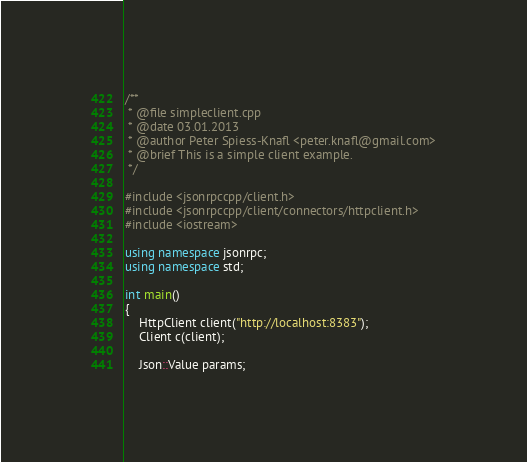<code> <loc_0><loc_0><loc_500><loc_500><_C++_>/**
 * @file simpleclient.cpp
 * @date 03.01.2013
 * @author Peter Spiess-Knafl <peter.knafl@gmail.com>
 * @brief This is a simple client example.
 */

#include <jsonrpccpp/client.h>
#include <jsonrpccpp/client/connectors/httpclient.h>
#include <iostream>

using namespace jsonrpc;
using namespace std;

int main()
{
    HttpClient client("http://localhost:8383");
    Client c(client);

    Json::Value params;</code> 